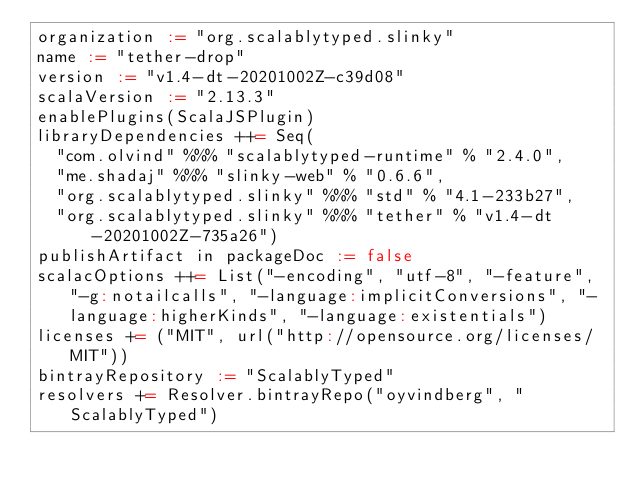Convert code to text. <code><loc_0><loc_0><loc_500><loc_500><_Scala_>organization := "org.scalablytyped.slinky"
name := "tether-drop"
version := "v1.4-dt-20201002Z-c39d08"
scalaVersion := "2.13.3"
enablePlugins(ScalaJSPlugin)
libraryDependencies ++= Seq(
  "com.olvind" %%% "scalablytyped-runtime" % "2.4.0",
  "me.shadaj" %%% "slinky-web" % "0.6.6",
  "org.scalablytyped.slinky" %%% "std" % "4.1-233b27",
  "org.scalablytyped.slinky" %%% "tether" % "v1.4-dt-20201002Z-735a26")
publishArtifact in packageDoc := false
scalacOptions ++= List("-encoding", "utf-8", "-feature", "-g:notailcalls", "-language:implicitConversions", "-language:higherKinds", "-language:existentials")
licenses += ("MIT", url("http://opensource.org/licenses/MIT"))
bintrayRepository := "ScalablyTyped"
resolvers += Resolver.bintrayRepo("oyvindberg", "ScalablyTyped")
</code> 